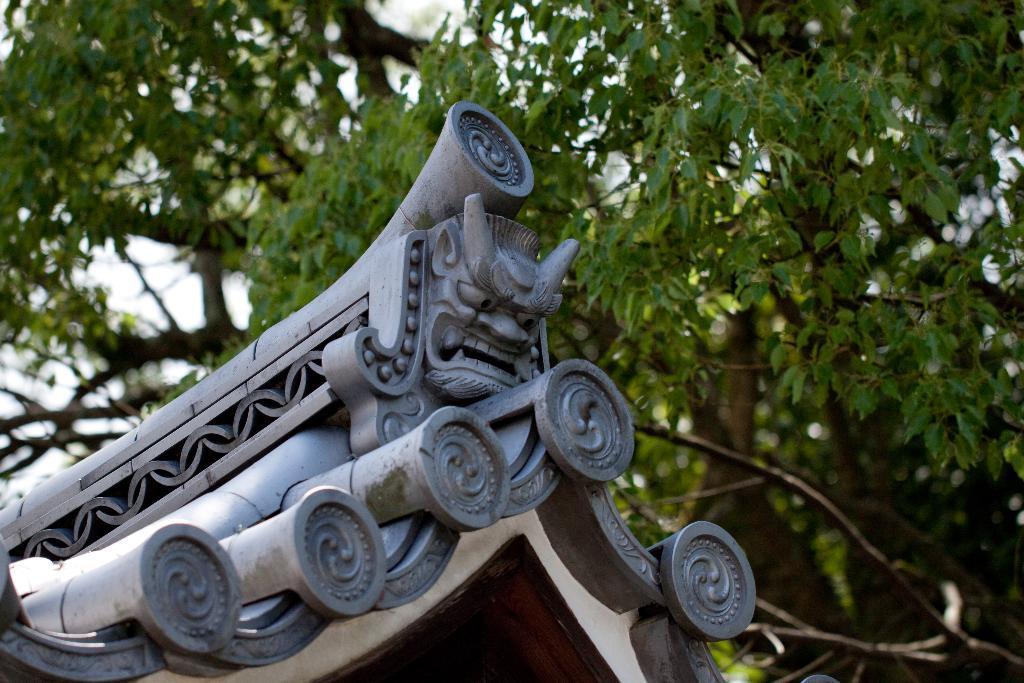Describe this image in one or two sentences. In this image we can see the roof and in the background, we can see trees. 